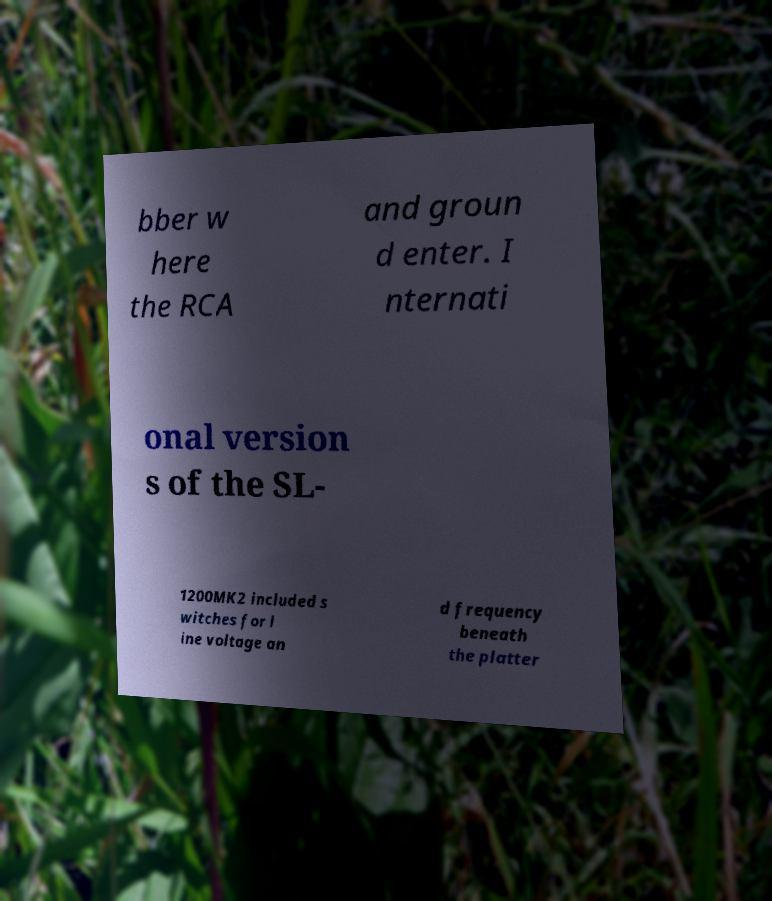What messages or text are displayed in this image? I need them in a readable, typed format. bber w here the RCA and groun d enter. I nternati onal version s of the SL- 1200MK2 included s witches for l ine voltage an d frequency beneath the platter 